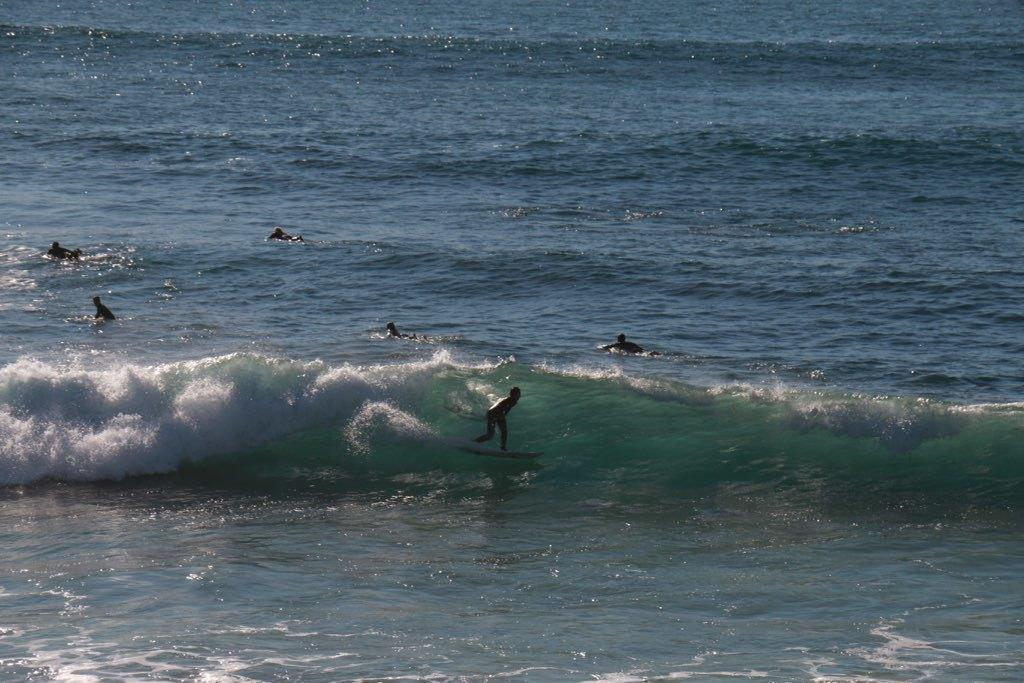What activity are the people in the image engaged in? The people in the image are surfing. What can be observed about the water in the image? The water appears to be flowing. What type of body of water might be depicted in the image? The image may depict a sea or ocean. What feature of the water can be seen in the image? There is a wave visible in the image. Can you see the writer's face in the image? There is no writer present in the image, as it depicts people surfing in a body of water. 